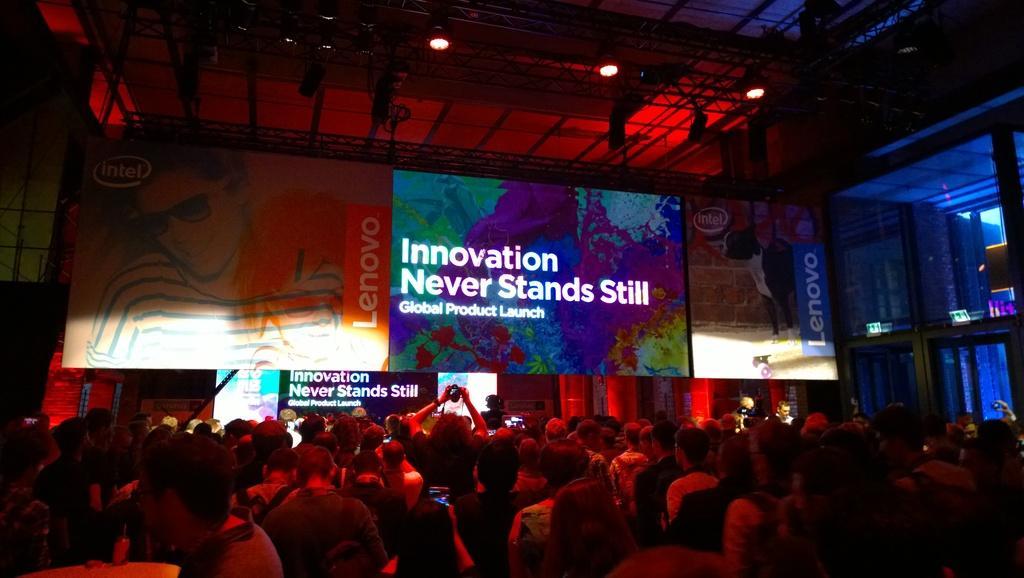How would you summarize this image in a sentence or two? At the top of the image we can see iron grills, electric lights, advertisement and dais. At the bottom of the image we can see people and some of them are holding cameras in their hands. 